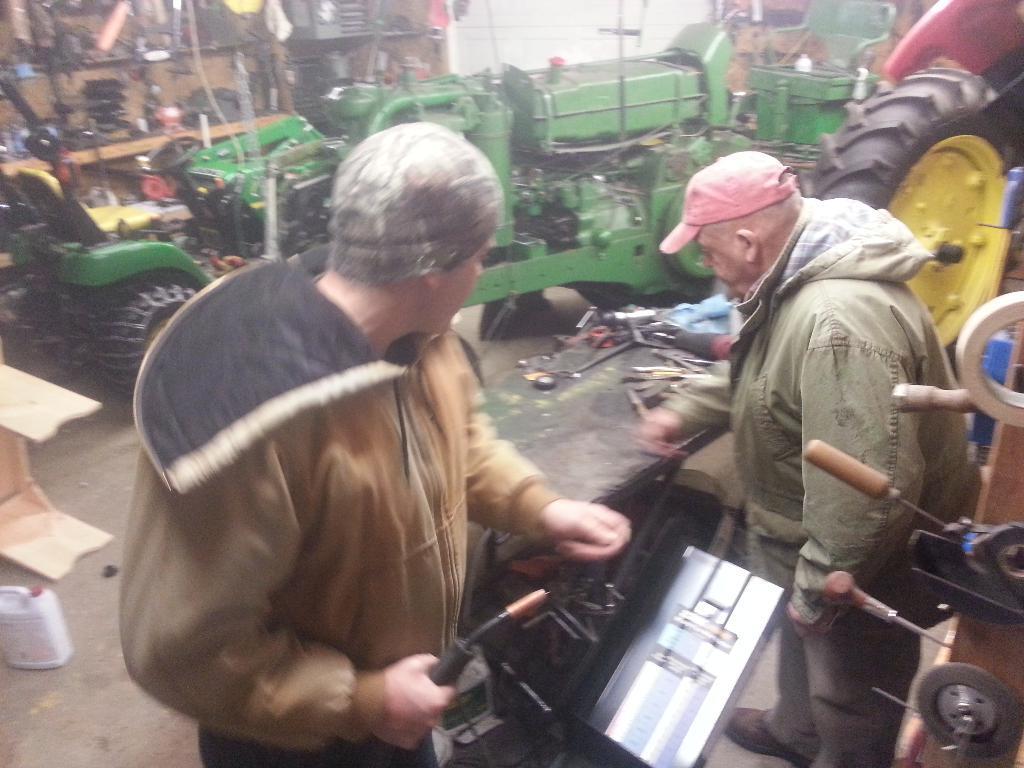Describe this image in one or two sentences. In this image I see 2 men and I see that both of them are wearing caps and I see a wheel over here. In the background I see a vehicle and I see few equipment over here and I see the path on which I see a bottle over here and I see that this man is holding a thing in his hand and I see few more things over here. 